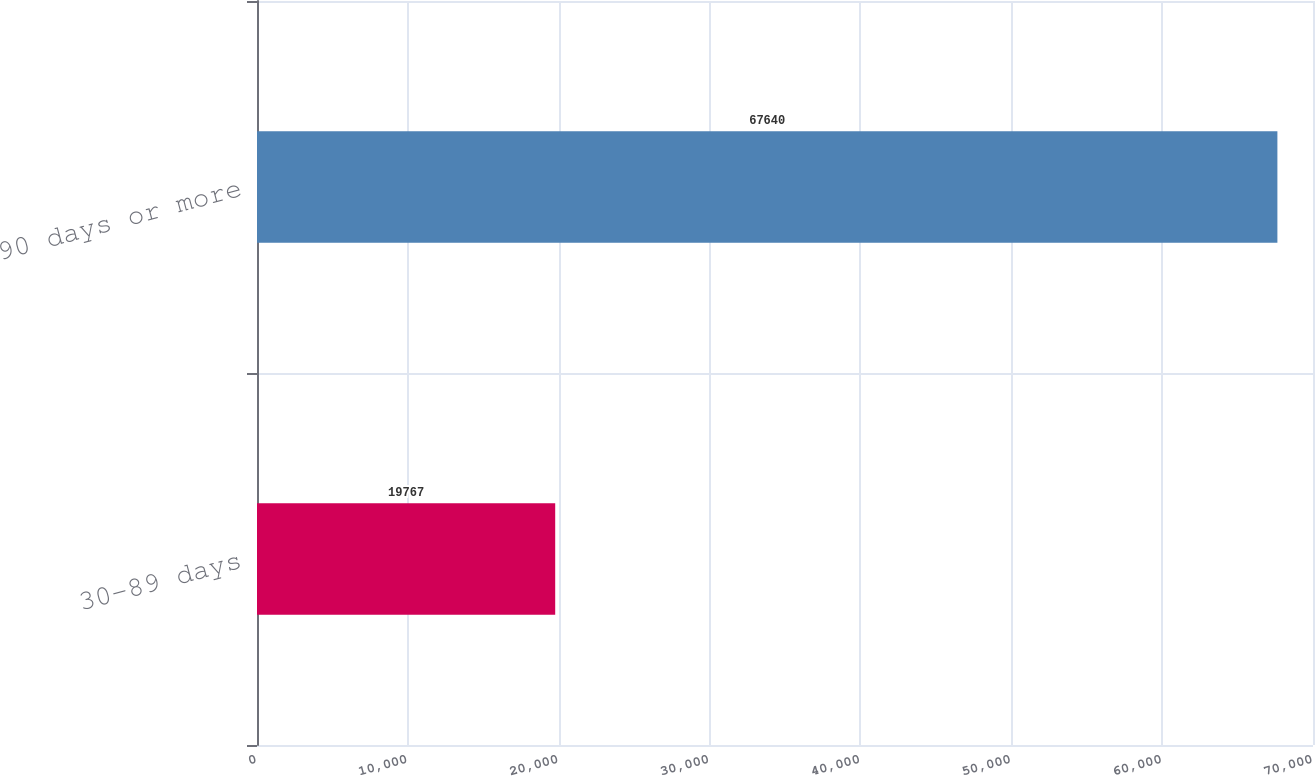<chart> <loc_0><loc_0><loc_500><loc_500><bar_chart><fcel>30-89 days<fcel>90 days or more<nl><fcel>19767<fcel>67640<nl></chart> 